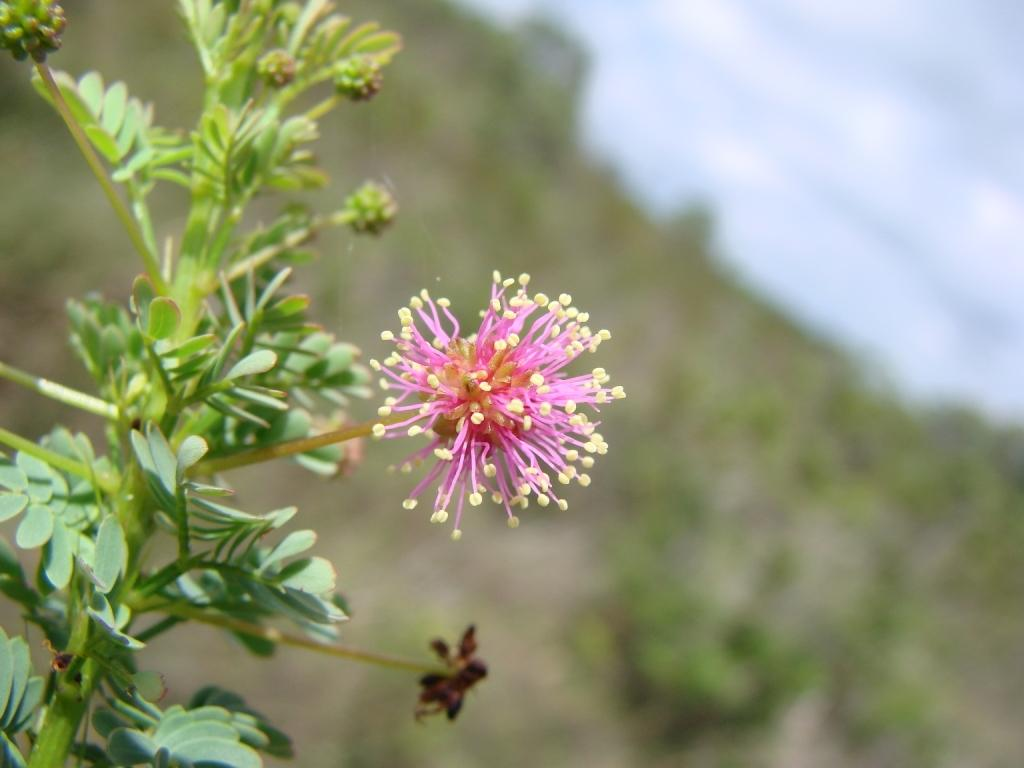What type of plant is visible in the image? There is a flower in the image. What parts of the plant can be seen besides the flower? There are stems and leaves in the image. How would you describe the background of the image? The background of the image is blurry. What type of teeth can be seen in the image? There are no teeth visible in the image; it features a flower, stems, and leaves. Can you see a card being smashed in the image? There is no card or smashing action present in the image. 